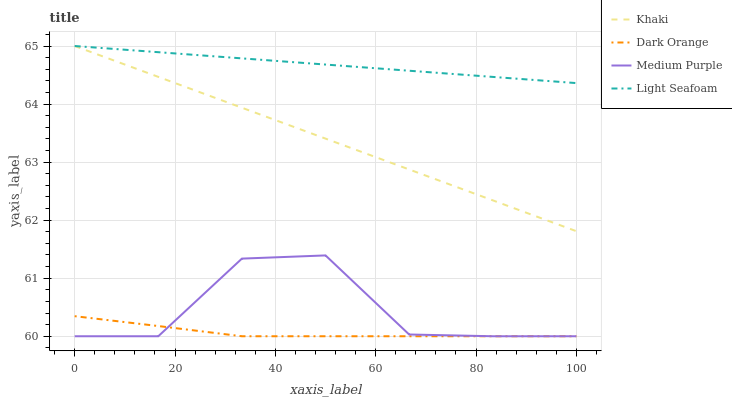Does Dark Orange have the minimum area under the curve?
Answer yes or no. Yes. Does Light Seafoam have the maximum area under the curve?
Answer yes or no. Yes. Does Khaki have the minimum area under the curve?
Answer yes or no. No. Does Khaki have the maximum area under the curve?
Answer yes or no. No. Is Khaki the smoothest?
Answer yes or no. Yes. Is Medium Purple the roughest?
Answer yes or no. Yes. Is Dark Orange the smoothest?
Answer yes or no. No. Is Dark Orange the roughest?
Answer yes or no. No. Does Medium Purple have the lowest value?
Answer yes or no. Yes. Does Khaki have the lowest value?
Answer yes or no. No. Does Light Seafoam have the highest value?
Answer yes or no. Yes. Does Dark Orange have the highest value?
Answer yes or no. No. Is Dark Orange less than Light Seafoam?
Answer yes or no. Yes. Is Khaki greater than Medium Purple?
Answer yes or no. Yes. Does Medium Purple intersect Dark Orange?
Answer yes or no. Yes. Is Medium Purple less than Dark Orange?
Answer yes or no. No. Is Medium Purple greater than Dark Orange?
Answer yes or no. No. Does Dark Orange intersect Light Seafoam?
Answer yes or no. No. 